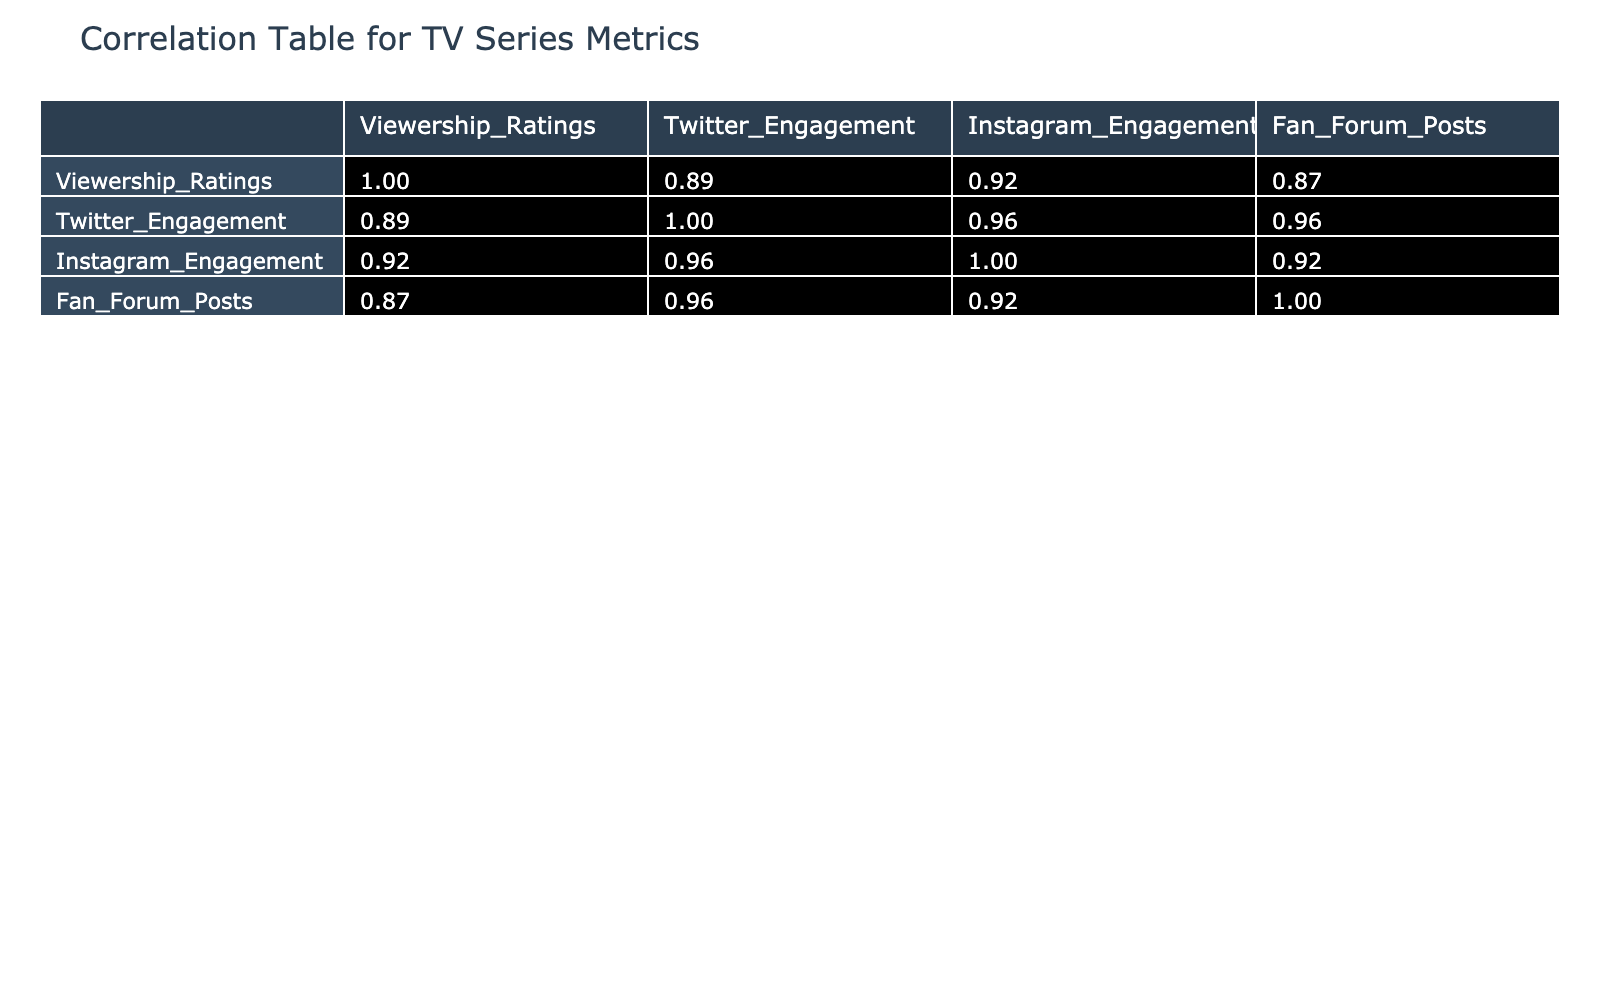What is the viewership rating of "The Bear"? The table shows a column for viewership ratings, and by locating "The Bear" in the Series column, the corresponding value is found to be 8.4.
Answer: 8.4 What series has the highest Twitter engagement? By examining the Twitter Engagement values, "Breaking Bad: El Camino" has the highest engagement at 25,000.
Answer: Breaking Bad: El Camino Is there a positive correlation between viewership ratings and Instagram engagement? To determine the presence of a positive correlation, we look at the correlation coefficient in the table between Viewership Ratings and Instagram Engagement, which is approximately 0.54, indicating a moderate positive correlation.
Answer: Yes What is the average Twitter engagement for all series listed? To find the average Twitter engagement, sum the Twitter Engagement values (15000 + 20000 + 18000 + 17000 + 16000 + 13000 + 14000 + 12000 + 25000 + 11000 = 171000) and divide by the number of series (10). Thus, the average is 171000 / 10 = 17100.
Answer: 17100 Which series has the lowest fan forum posts and what is that number? The series "Wednesday" has the lowest number of fan forum posts at 300, by scanning the Fan Forum Posts column.
Answer: 300 Is the viewership rating for "Yellowjackets" above 8.0? Looking at the Viewership Ratings for "Yellowjackets," which is 7.9, confirms that it is not above 8.0.
Answer: No How much higher is the Instagram engagement of "Breaking Bad: El Camino" compared to "The Marvelous Mrs. Maisel"? First, we find the Instagram engagement for both shows, which are 18000 for "Breaking Bad: El Camino" and 9500 for "The Marvelous Mrs. Maisel." The difference is 18000 - 9500 = 8500.
Answer: 8500 Is there a negative correlation between viewership ratings and fan forum posts? Checking the correlation coefficient for Viewership Ratings and Fan Forum Posts, which yields a value around -0.05, shows no significant negative correlation.
Answer: No What is the total engagement (Twitter + Instagram) for "House of the Dragon"? The total engagement is calculated by adding Twitter and Instagram engagement: 16000 (Twitter) + 11000 (Instagram) = 27000.
Answer: 27000 